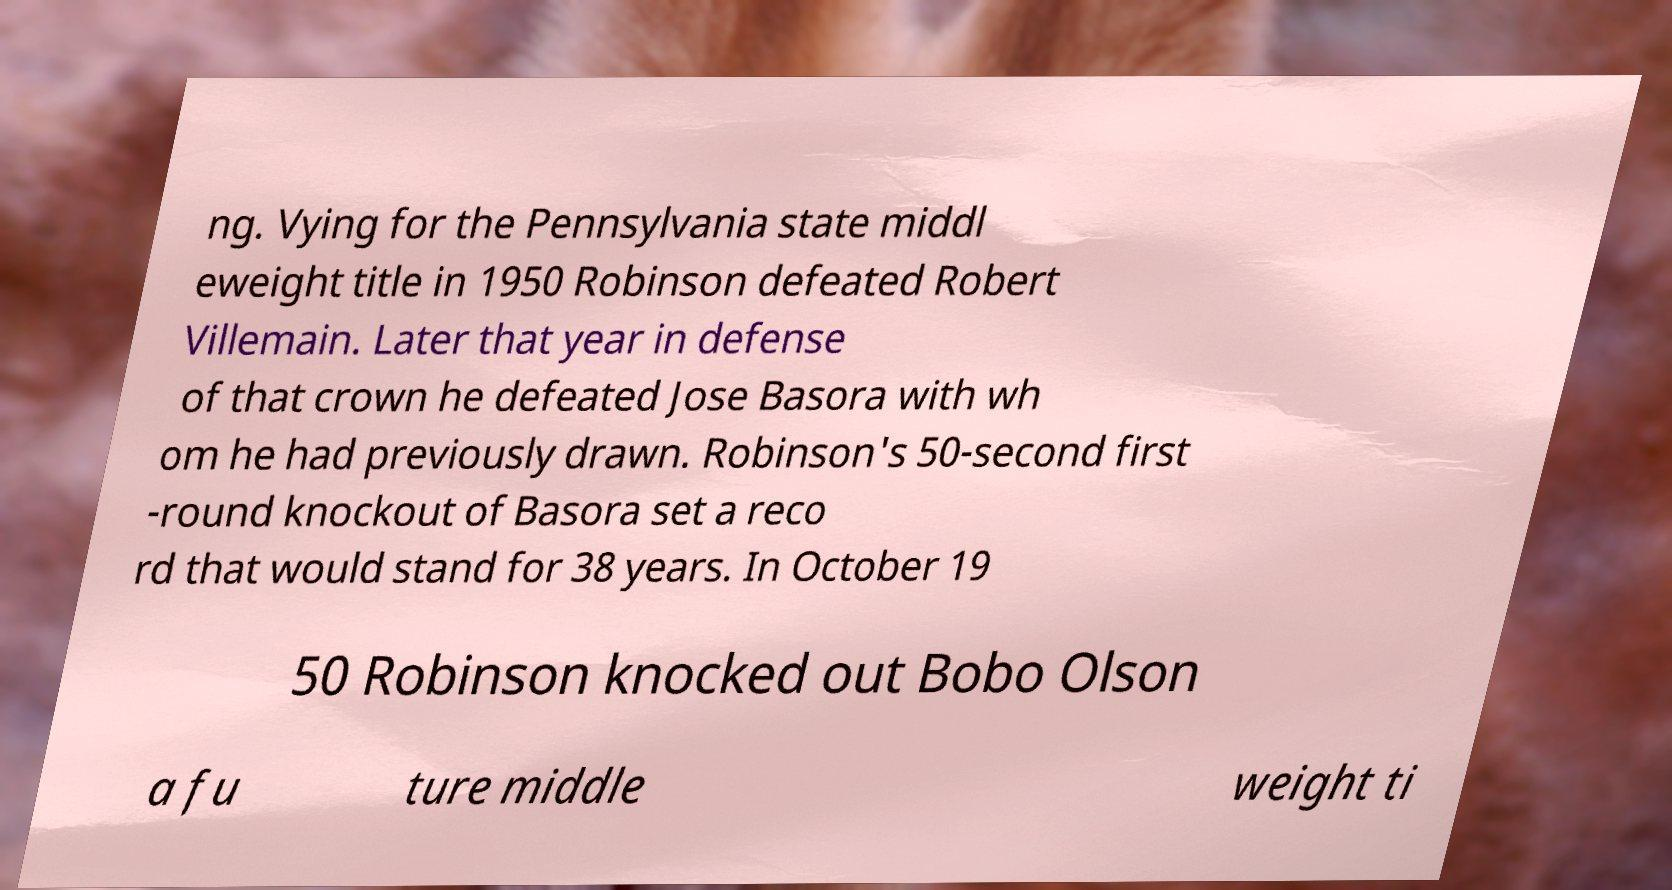There's text embedded in this image that I need extracted. Can you transcribe it verbatim? ng. Vying for the Pennsylvania state middl eweight title in 1950 Robinson defeated Robert Villemain. Later that year in defense of that crown he defeated Jose Basora with wh om he had previously drawn. Robinson's 50-second first -round knockout of Basora set a reco rd that would stand for 38 years. In October 19 50 Robinson knocked out Bobo Olson a fu ture middle weight ti 